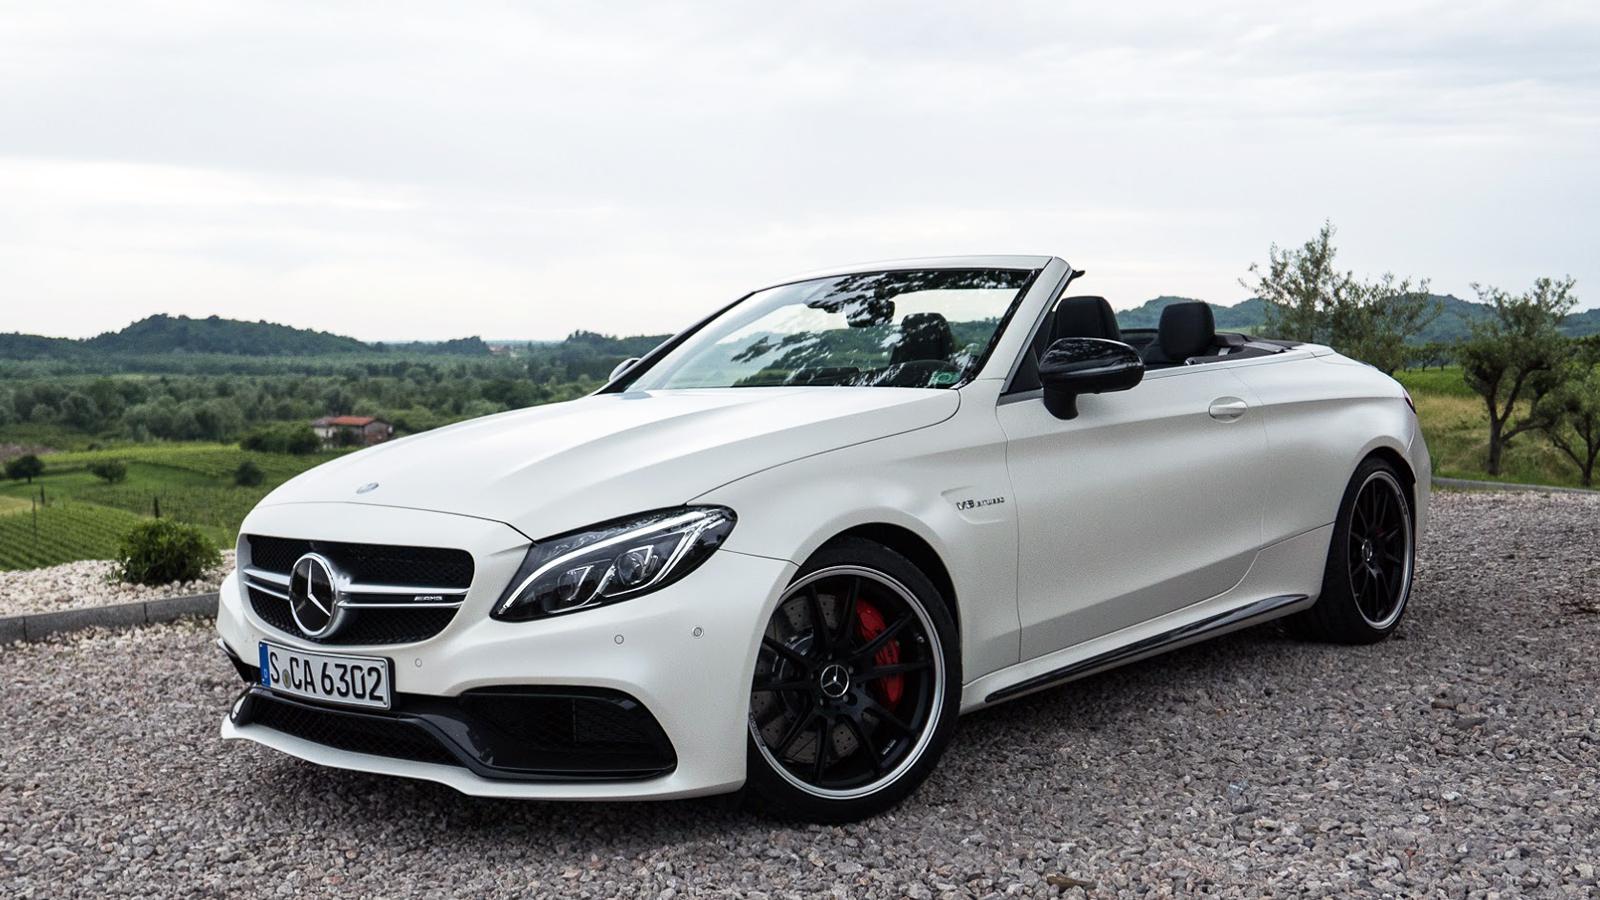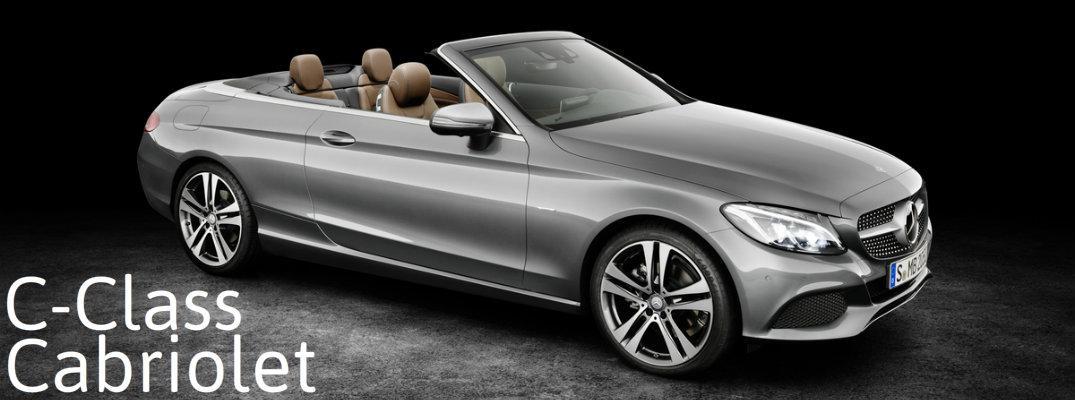The first image is the image on the left, the second image is the image on the right. For the images displayed, is the sentence "One image shows a white convertible with its top covered." factually correct? Answer yes or no. No. The first image is the image on the left, the second image is the image on the right. Examine the images to the left and right. Is the description "In one of the images there is a convertible parked outside with a building visible in the background." accurate? Answer yes or no. No. 